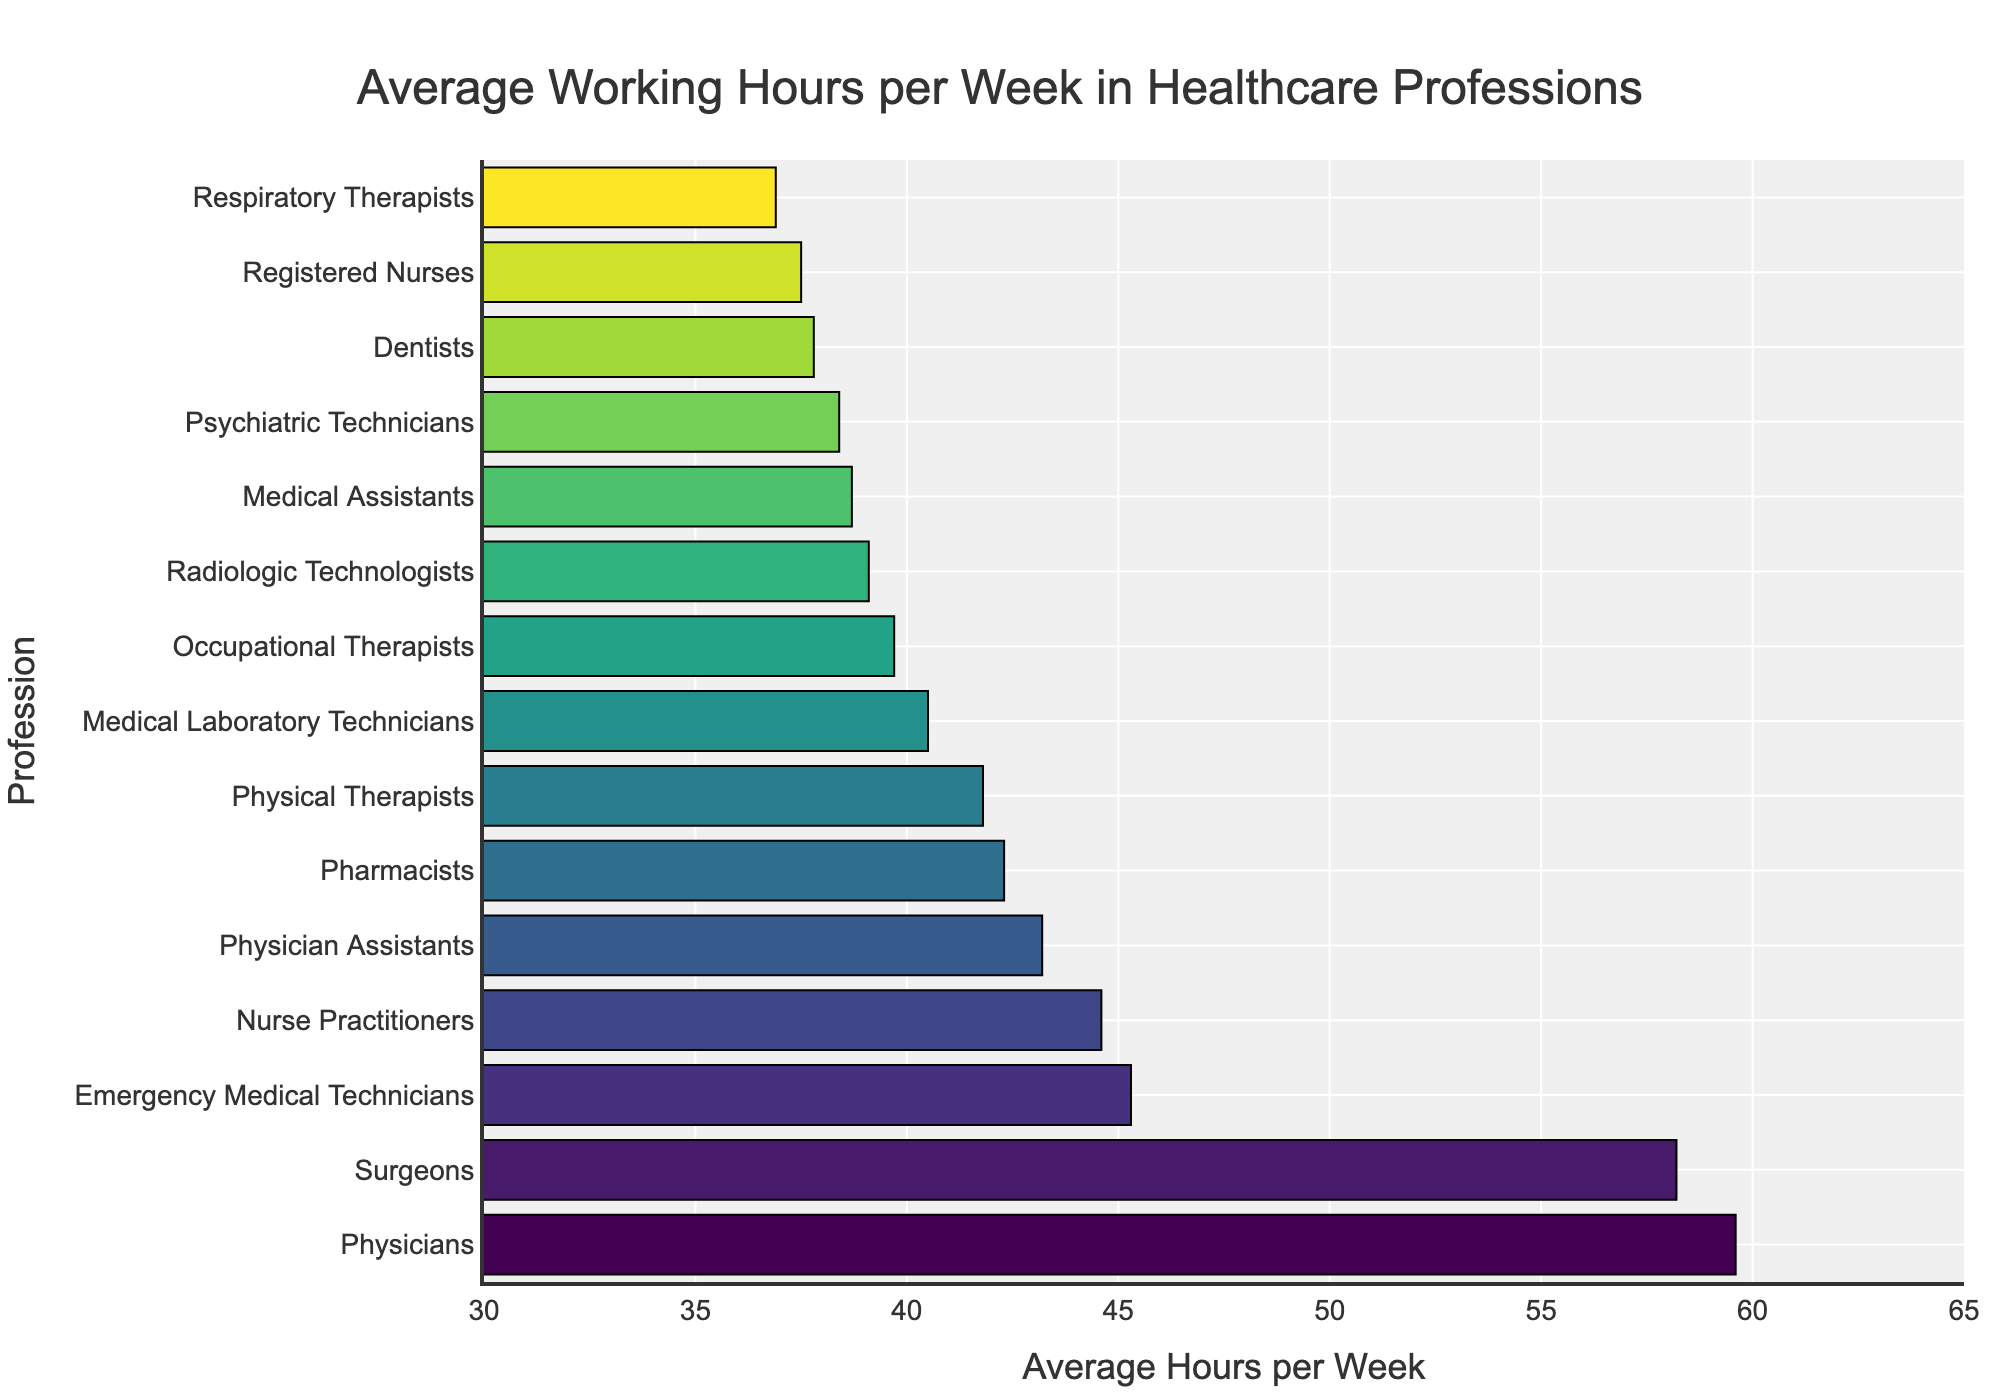Which healthcare profession has the highest average working hours per week? By looking at the bar chart, identify the longest bar. The longest bar corresponds to the profession with the highest average working hours per week, which is Physicians.
Answer: Physicians Which healthcare profession has the lowest average working hours per week? By looking at the bar chart, identify the shortest bar. The shortest bar corresponds to the profession with the lowest average working hours per week, which is Respiratory Therapists.
Answer: Respiratory Therapists What is the average difference in working hours between Physicians and Registered Nurses? Subtract the average working hours of Registered Nurses from the average working hours of Physicians (59.6 - 37.5).
Answer: 22.1 How many professions have an average working hours greater than 40 hours per week? Count the number of bars that extend beyond the 40-hour mark on the x-axis. By visually inspecting the chart, there are 8 professions with more than 40 hours per week.
Answer: 8 What is the combined average working hours of Surgeons and Emergency Medical Technicians? Sum the average working hours of Surgeons and Emergency Medical Technicians (58.2 + 45.3).
Answer: 103.5 Which profession works more on average: Nurse Practitioners or Dentists? Compare the length of the bars for Nurse Practitioners and Dentists. Nurse Practitioners have longer bars, indicating they work more on average.
Answer: Nurse Practitioners Arrange the Registered Nurses, Physical Therapists, and Pharmacists in ascending order of their average working hours per week. Compare the lengths of the bars for the three professions and arrange them from shortest to longest. The order is Registered Nurses (37.5), Physical Therapists (41.8), and Pharmacists (42.3).
Answer: Registered Nurses, Physical Therapists, Pharmacists Which professional group works close to 40 hours per week on average? Identify the bars whose lengths are around the 40-hour mark. Professions close to this mark include Medical Assistants (38.7), Radiologic Technologists (39.1), Occupational Therapists (39.7), and Medical Laboratory Technicians (40.5).
Answer: Medical Assistants, Radiologic Technologists, Occupational Therapists, Medical Laboratory Technicians What is the difference in average working hours between the profession with the second-highest and second-lowest average working hours? Identify the second-highest and second-lowest bars. Surgeons have the second-highest (58.2), and Respiratory Therapists have the second-lowest (36.9). Subtract the latter from the former (58.2 - 36.9).
Answer: 21.3 If you combine the average working hours of Physician Assistants and Psychiatric Technicians, do they work more than Surgeons on average? Sum the working hours of Physician Assistants and Psychiatric Technicians (43.2 + 38.4). Compare this sum to the working hours of Surgeons (58.2). The combined sum (81.6) is greater than 58.2.
Answer: Yes 